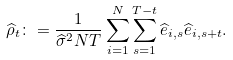<formula> <loc_0><loc_0><loc_500><loc_500>\widehat { \rho } _ { t } \colon = \frac { 1 } { \widehat { \sigma } ^ { 2 } N T } \sum _ { i = 1 } ^ { N } \sum _ { s = 1 } ^ { T - t } \widehat { e } _ { i , s } \widehat { e } _ { i , s + t } .</formula> 